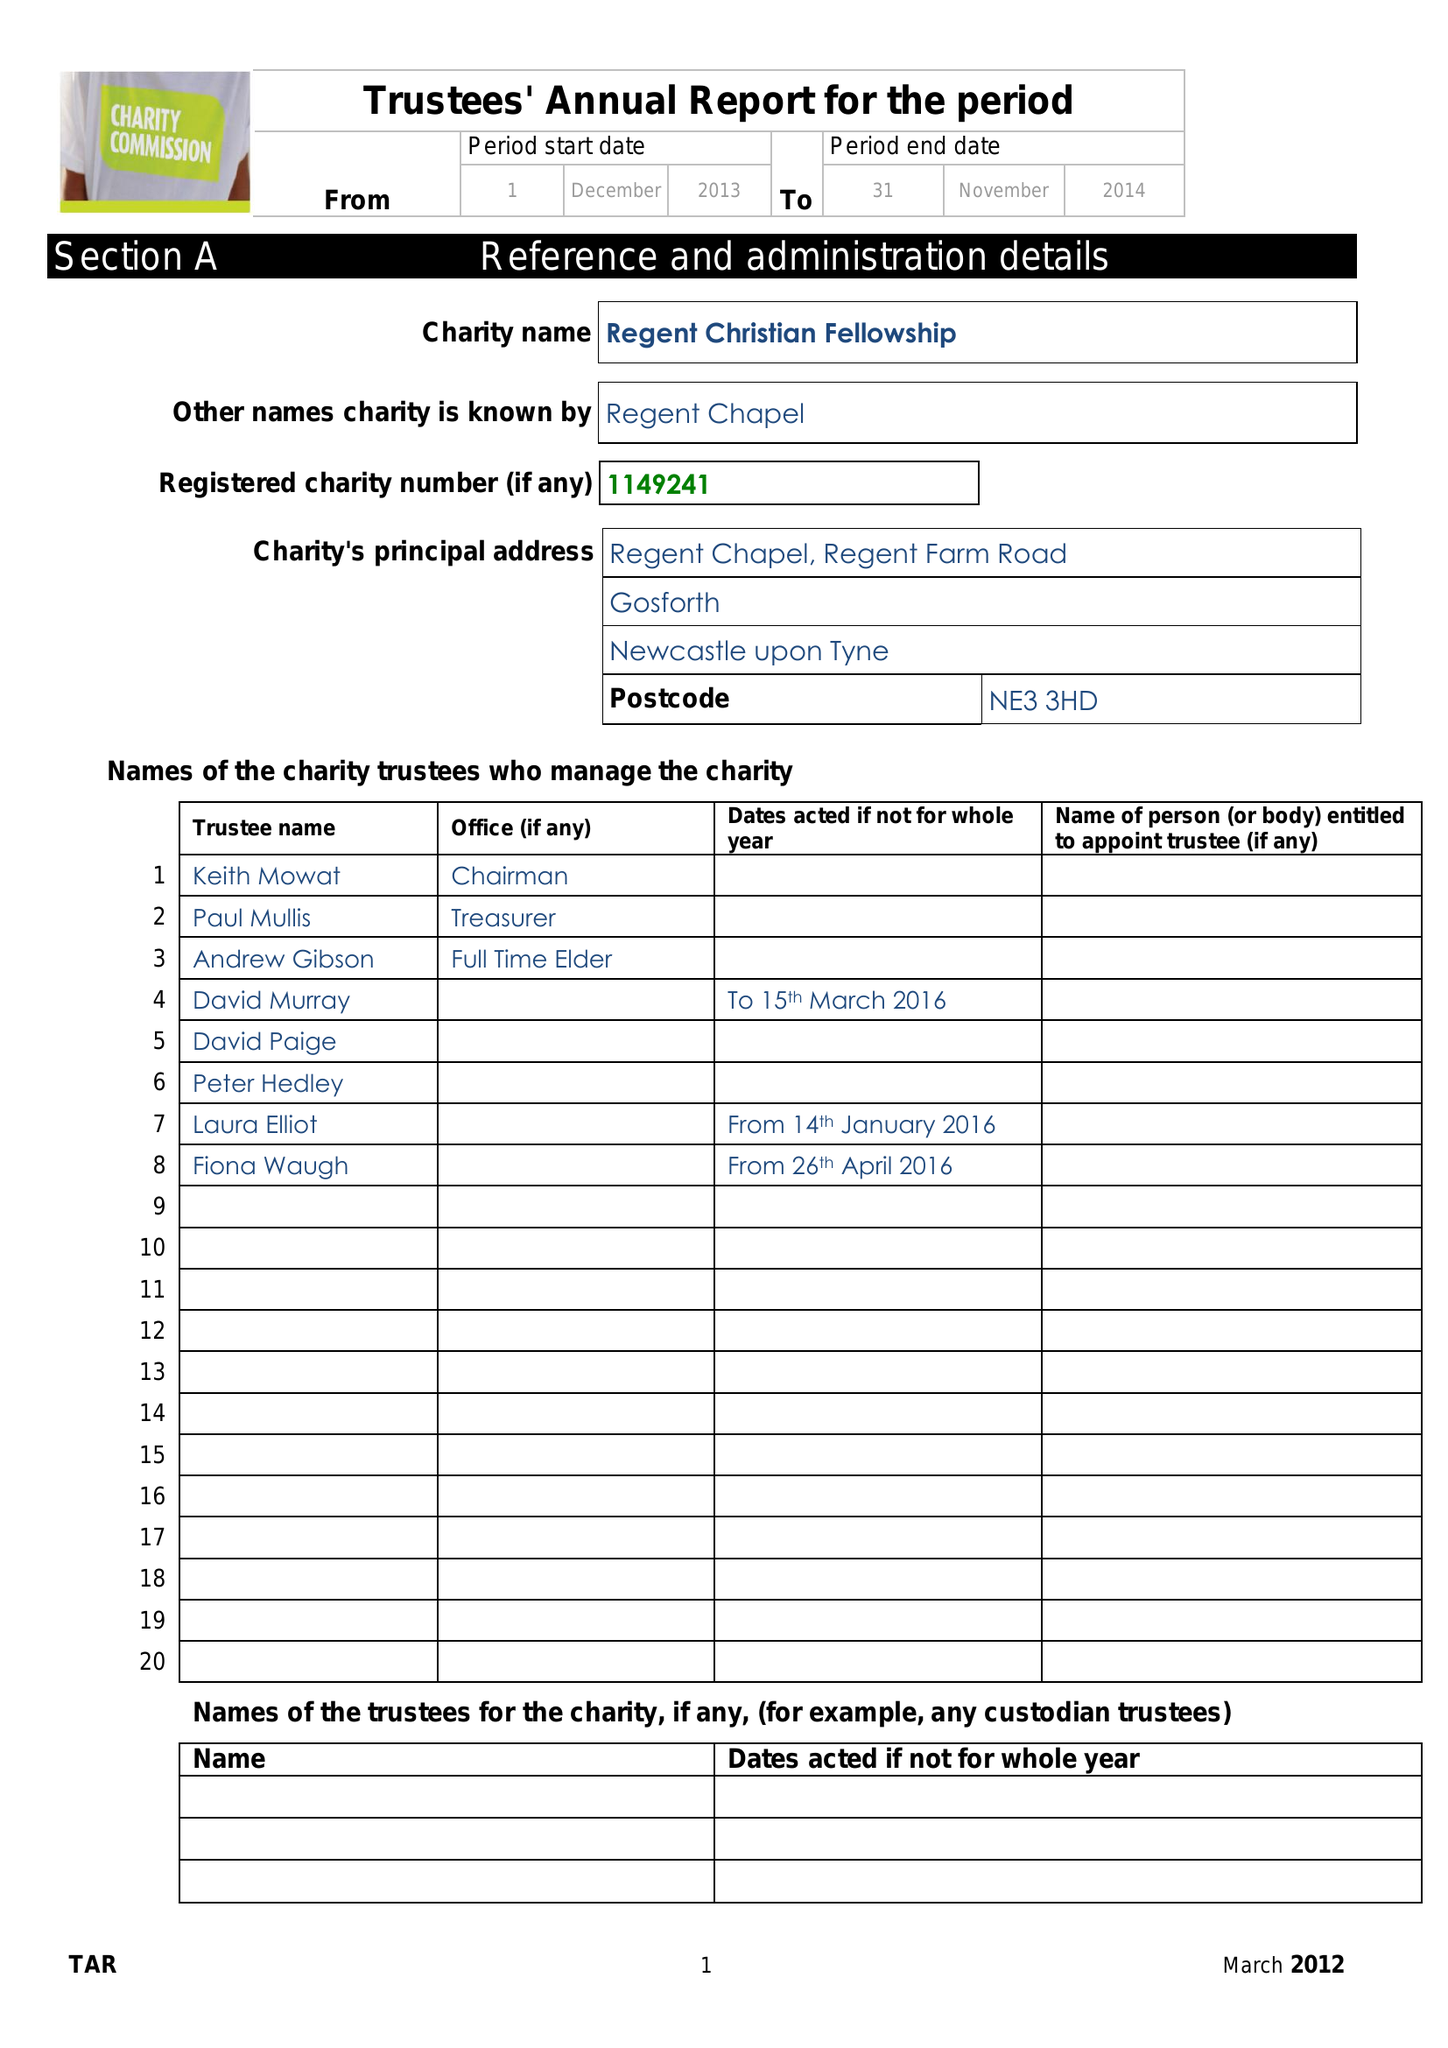What is the value for the income_annually_in_british_pounds?
Answer the question using a single word or phrase. 108829.00 